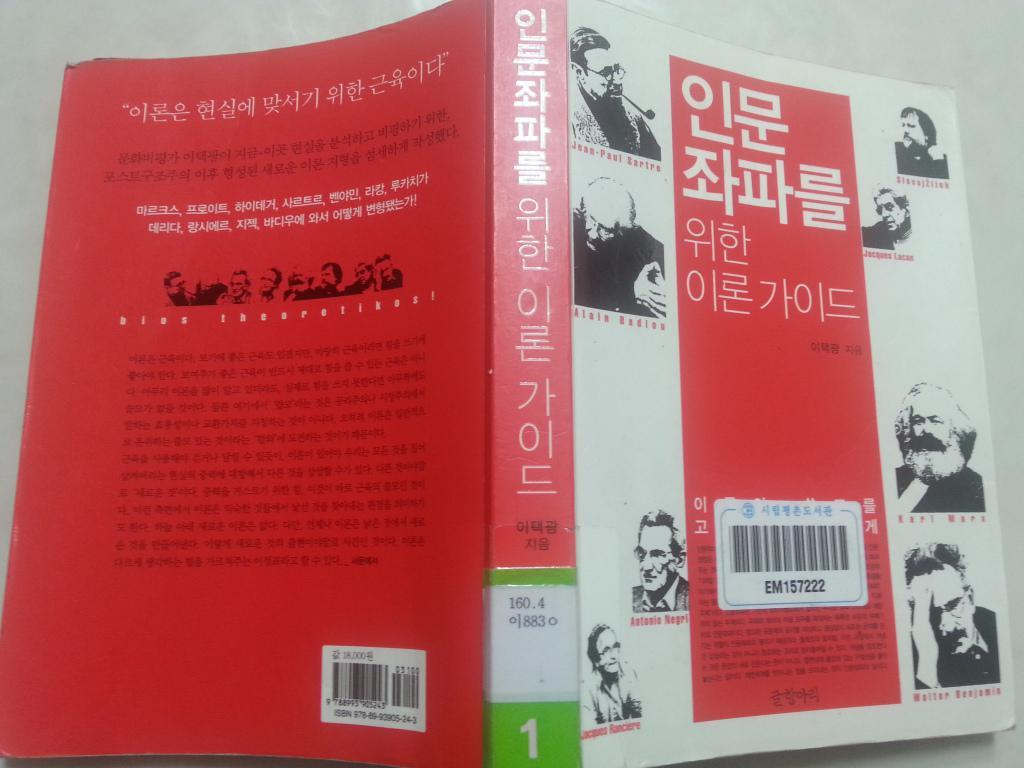Provide a one-sentence caption for the provided image. The book in Korean language has a bar code number EM157222. 